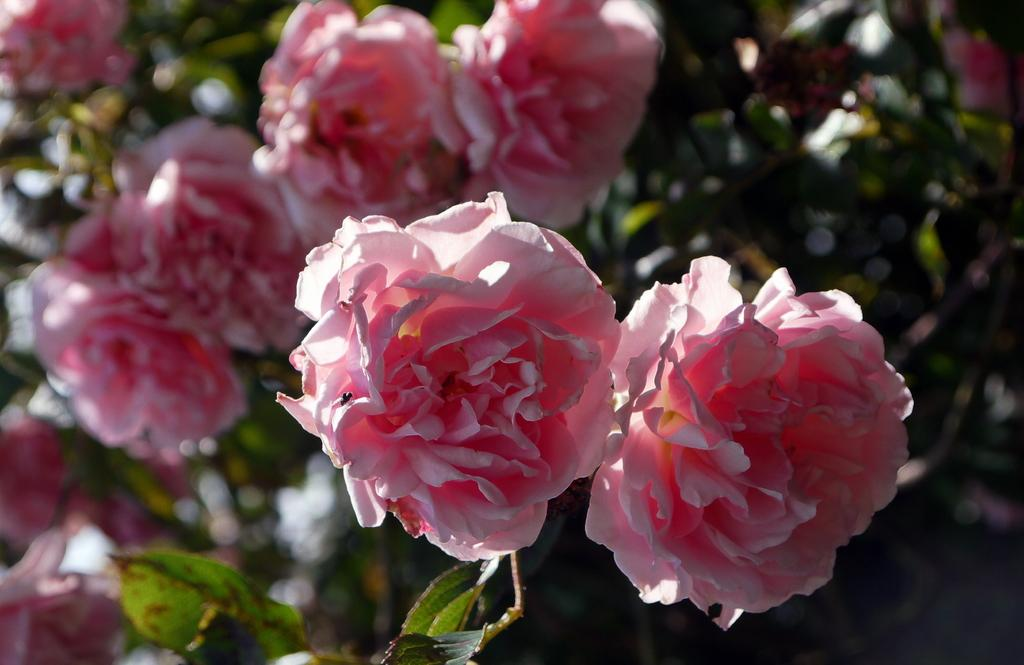What type of plants or trees are present in the image? There are plants or trees with flowers in the image. What color are the flowers on these plants or trees? The flowers are pink. What can be seen in the background of the image? There are trees in the background of the image. How is the background of the image depicted? The background of the image is blurred. What type of music can be heard playing in the background of the image? There is no music present in the image; it is a still photograph of plants or trees with flowers. 